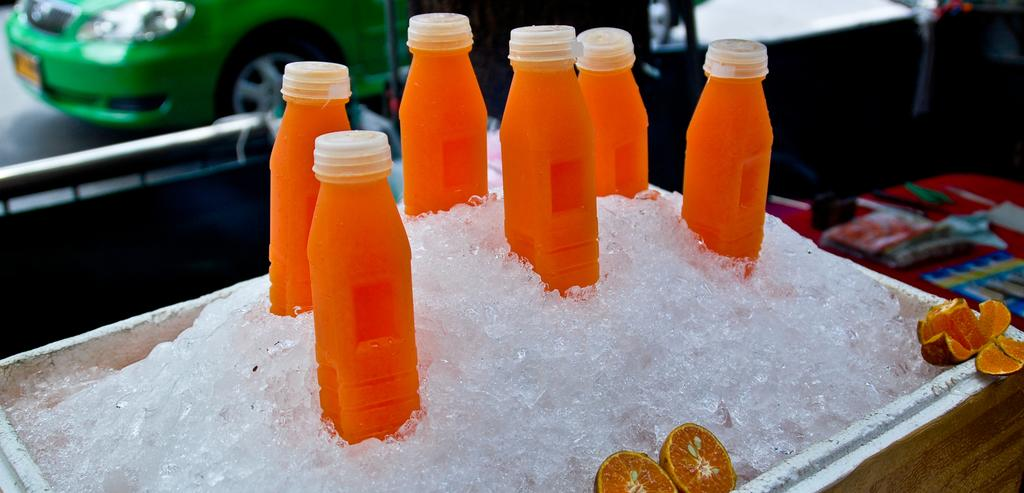What is inside the box that is visible in the image? There is a box containing ice lemon in the image. What else can be seen in the image besides the box? There are bottles and objects on the table in the image. Can you describe the background of the image? There is a car visible on the road in the background of the image. What type of badge is the uncle wearing in the image? There is no uncle or badge present in the image. What form is the ice lemon taking in the image? The ice lemon is in a solid form, contained within the box. 